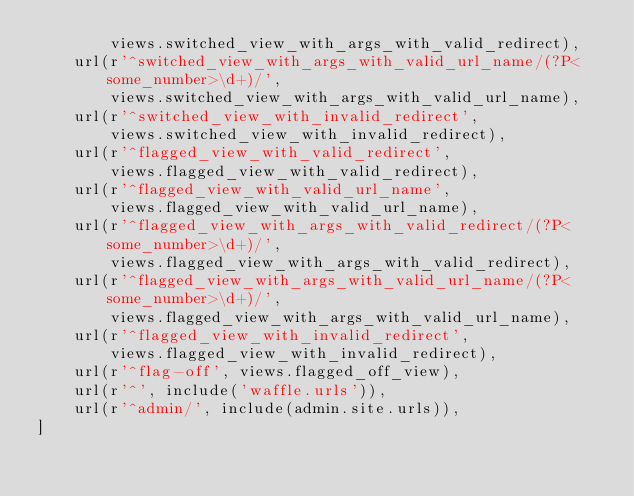Convert code to text. <code><loc_0><loc_0><loc_500><loc_500><_Python_>        views.switched_view_with_args_with_valid_redirect),
    url(r'^switched_view_with_args_with_valid_url_name/(?P<some_number>\d+)/',
        views.switched_view_with_args_with_valid_url_name),
    url(r'^switched_view_with_invalid_redirect',
        views.switched_view_with_invalid_redirect),
    url(r'^flagged_view_with_valid_redirect',
        views.flagged_view_with_valid_redirect),
    url(r'^flagged_view_with_valid_url_name',
        views.flagged_view_with_valid_url_name),
    url(r'^flagged_view_with_args_with_valid_redirect/(?P<some_number>\d+)/',
        views.flagged_view_with_args_with_valid_redirect),
    url(r'^flagged_view_with_args_with_valid_url_name/(?P<some_number>\d+)/',
        views.flagged_view_with_args_with_valid_url_name),
    url(r'^flagged_view_with_invalid_redirect',
        views.flagged_view_with_invalid_redirect),
    url(r'^flag-off', views.flagged_off_view),
    url(r'^', include('waffle.urls')),
    url(r'^admin/', include(admin.site.urls)),
]
</code> 